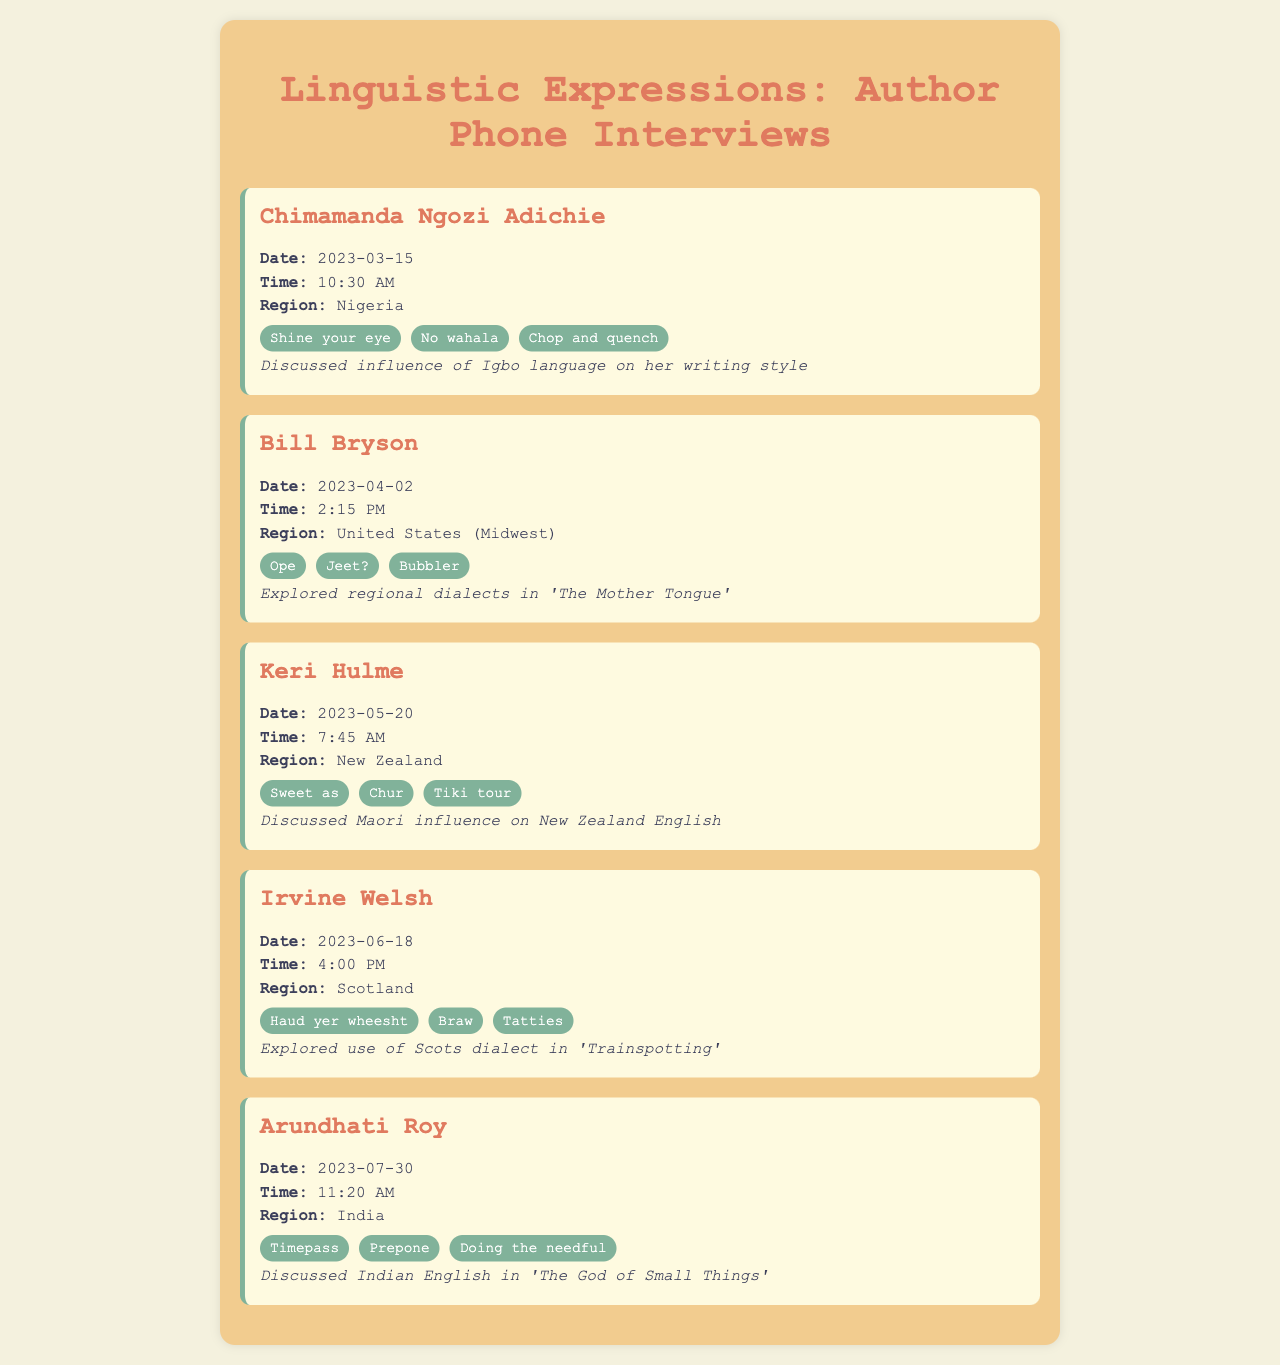What is the name of the author interviewed on March 15, 2023? The document states that Chimamanda Ngozi Adichie was interviewed on that date.
Answer: Chimamanda Ngozi Adichie What region does Bill Bryson represent? The document explicitly mentions the region associated with Bill Bryson as the United States (Midwest).
Answer: United States (Midwest) How many expressions were noted for Irvine Welsh? The document lists three expressions associated with Irvine Welsh during his interview.
Answer: Three What linguistic influence did Keri Hulme discuss? Keri Hulme talked about the influence of Maori on New Zealand English during her interview.
Answer: Maori What is the last name of the author who discussed Indian English? The document includes Arundhati Roy as the author who discussed Indian English.
Answer: Roy Which expression means “be quiet” in Scots? The expression "Haud yer wheesht" means "be quiet" as per the information from Irvine Welsh's interview.
Answer: Haud yer wheesht What time was Arundhati Roy's interview scheduled? The document indicates that Arundhati Roy's interview was scheduled at 11:20 AM.
Answer: 11:20 AM Which interview focused on regional dialects? Bill Bryson's interview explored regional dialects as mentioned in the document.
Answer: Bill Bryson How many unique expressions did Chimamanda Ngozi Adichie use? The document records three unique expressions used by Chimamanda Ngozi Adichie.
Answer: Three 